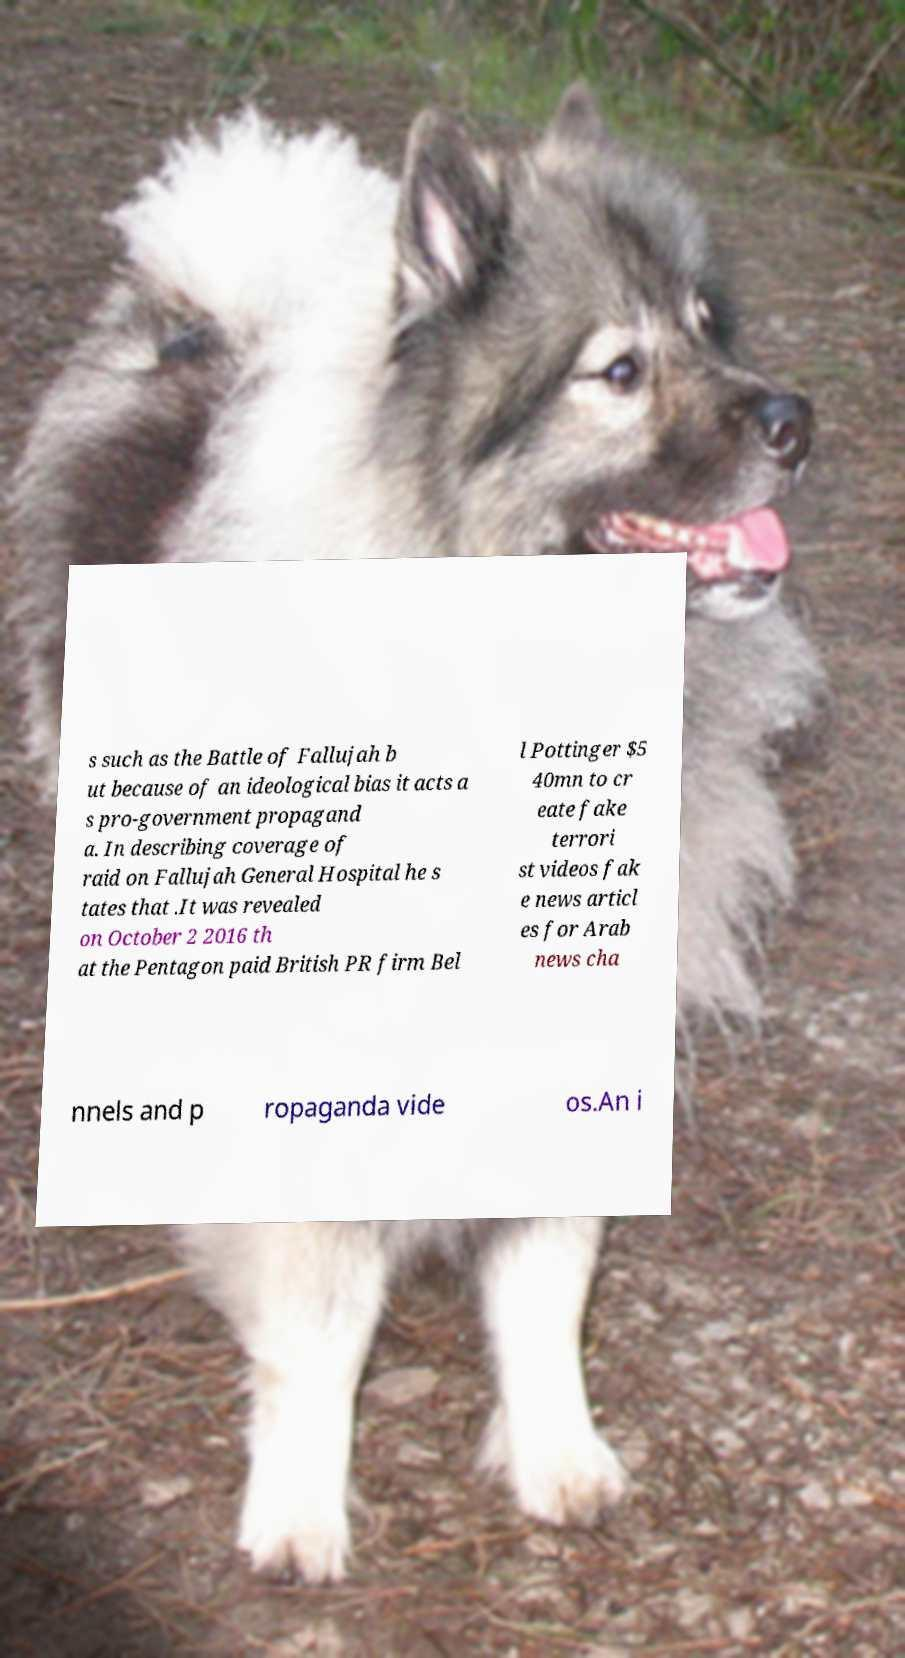Can you read and provide the text displayed in the image?This photo seems to have some interesting text. Can you extract and type it out for me? s such as the Battle of Fallujah b ut because of an ideological bias it acts a s pro-government propagand a. In describing coverage of raid on Fallujah General Hospital he s tates that .It was revealed on October 2 2016 th at the Pentagon paid British PR firm Bel l Pottinger $5 40mn to cr eate fake terrori st videos fak e news articl es for Arab news cha nnels and p ropaganda vide os.An i 